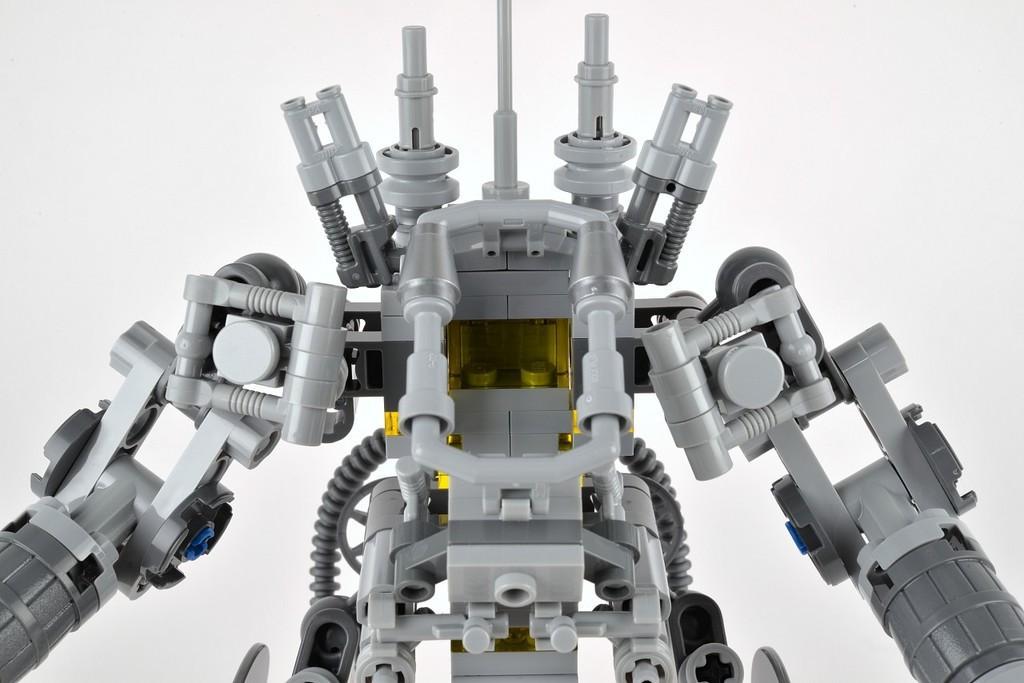Describe this image in one or two sentences. In this picture we can see a toy robot and in the background we can see white color. 